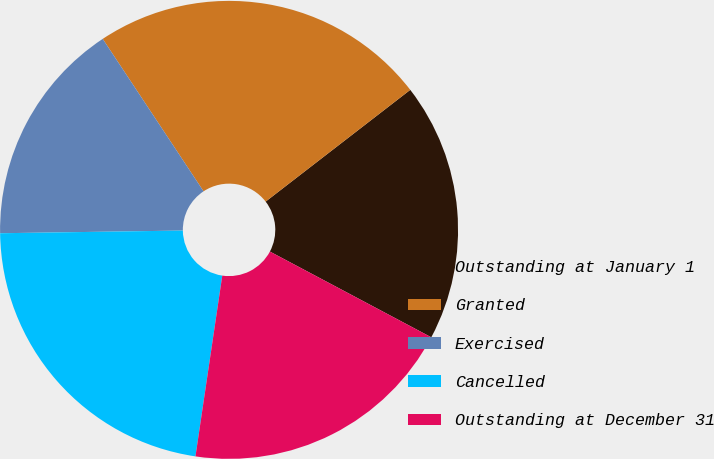<chart> <loc_0><loc_0><loc_500><loc_500><pie_chart><fcel>Outstanding at January 1<fcel>Granted<fcel>Exercised<fcel>Cancelled<fcel>Outstanding at December 31<nl><fcel>18.24%<fcel>23.83%<fcel>15.93%<fcel>22.42%<fcel>19.57%<nl></chart> 